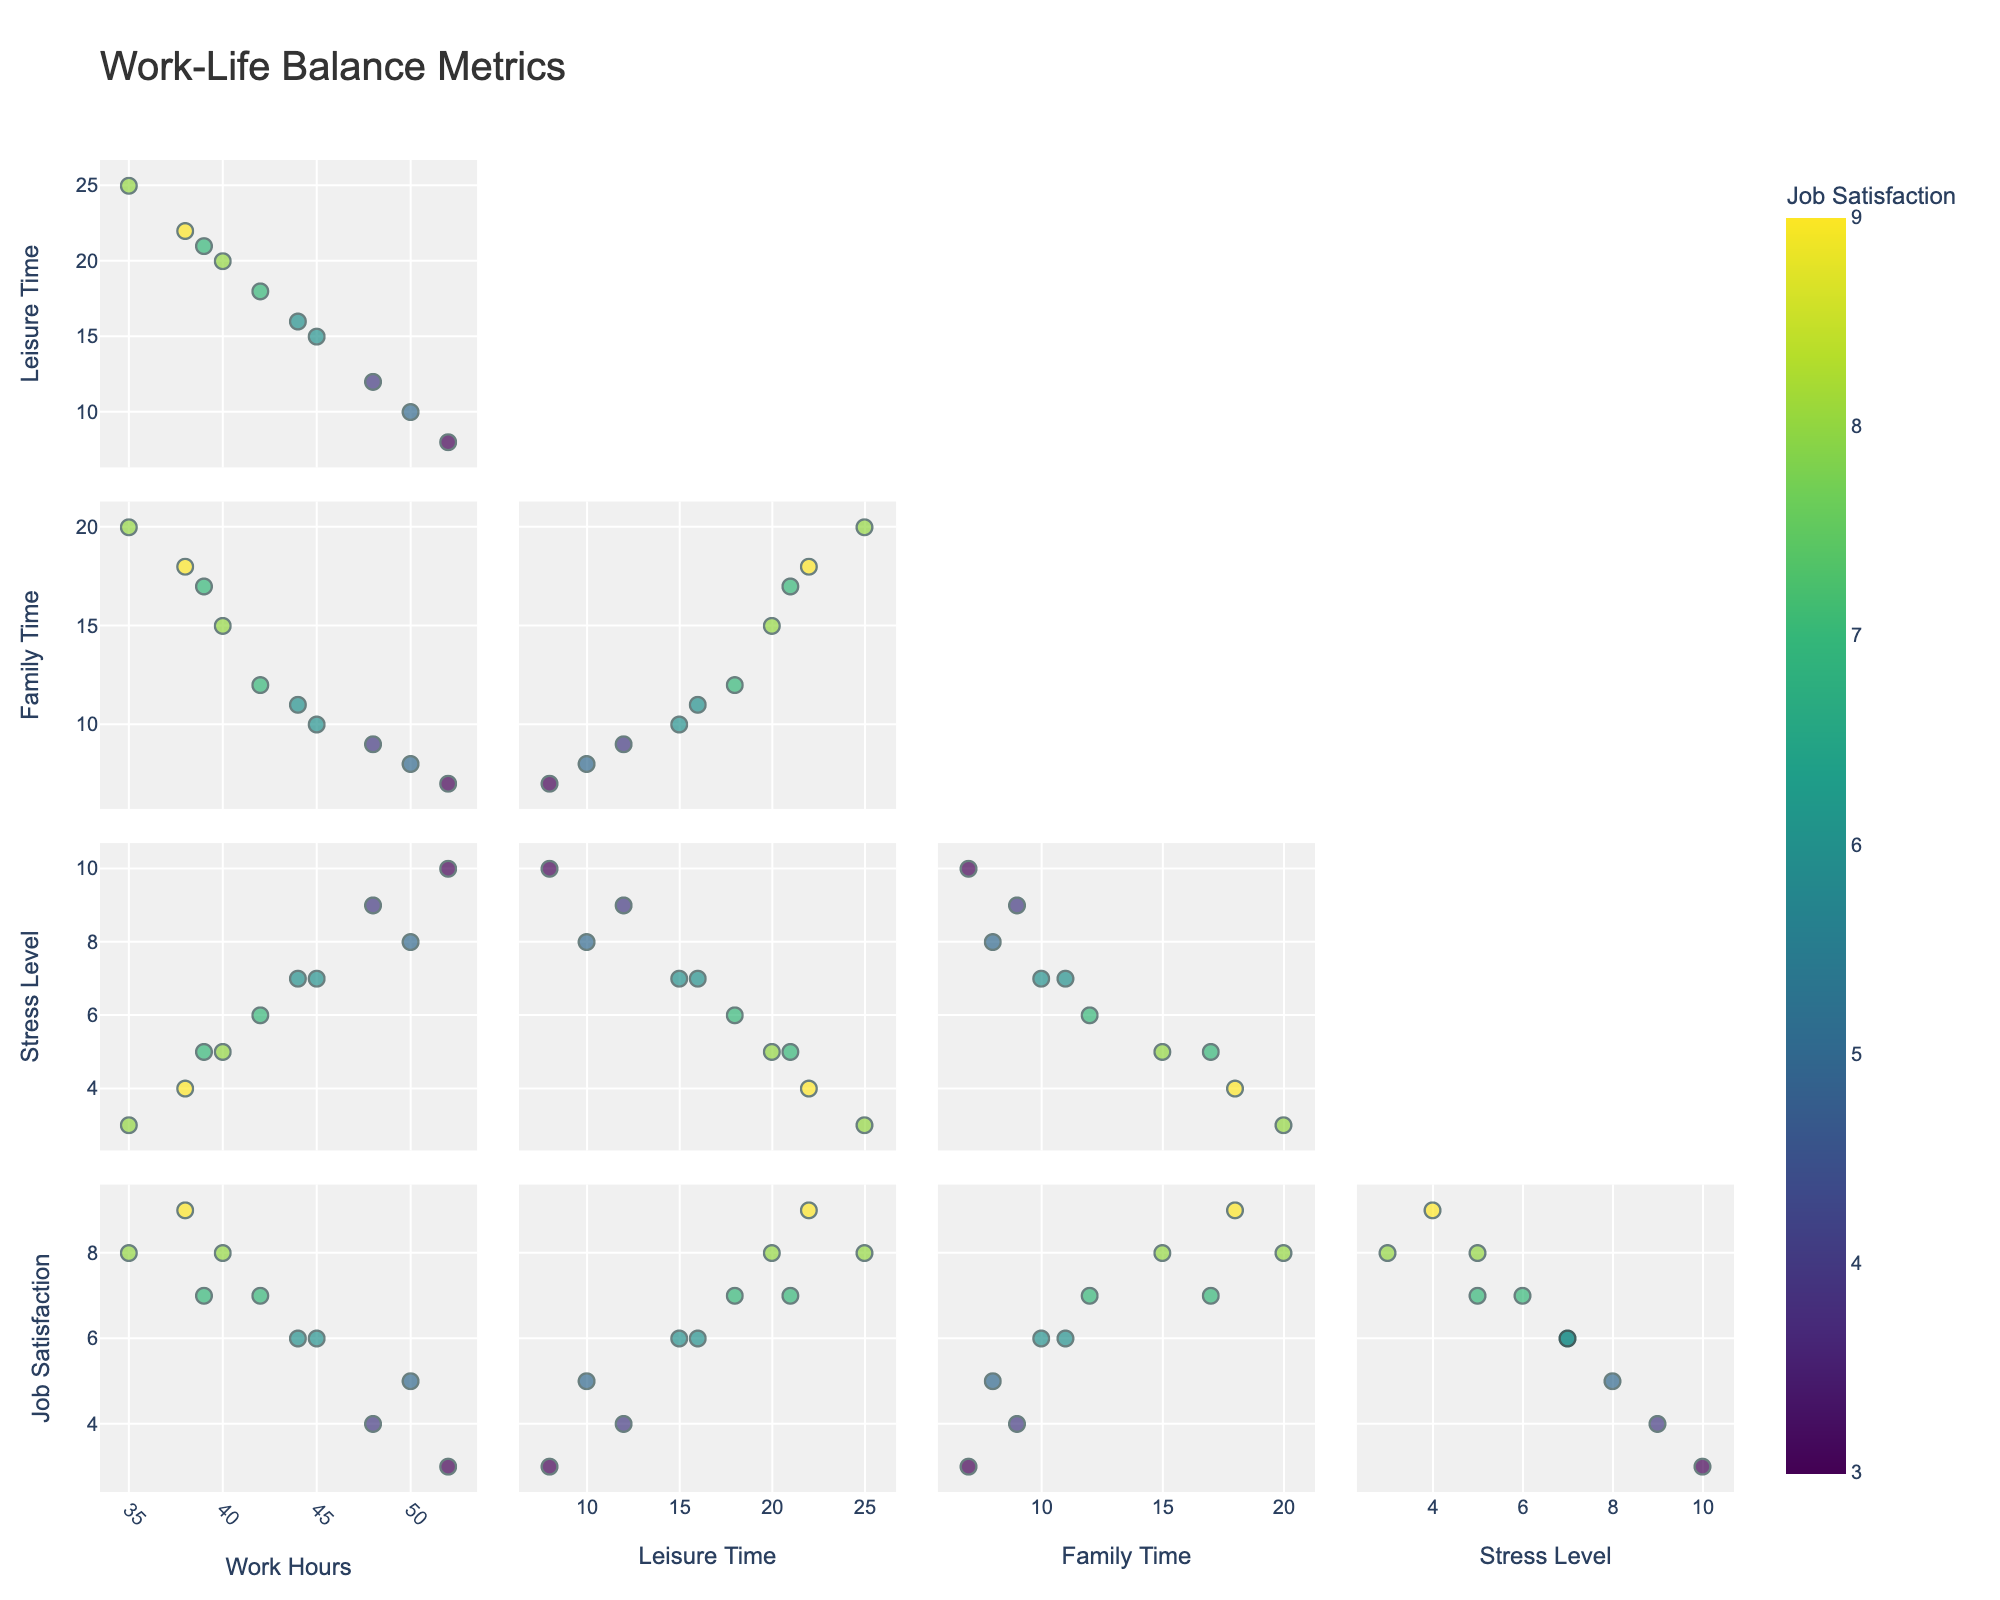How many subplots are present in the figure? There are three subplots in the figure, each representing a different fish species: Amazon Catfish, Peacock Bass, and Piranha.
Answer: 3 What is the title of the entire figure? The title of the entire figure is located at the top and reads "River Fish Populations vs Rainfall."
Answer: River Fish Populations vs Rainfall Which fish species has the highest population in the year with the maximum rainfall? The year with the maximum rainfall is 2005, with 2400 mm. In 2005, the fish populations are as follows: Amazon Catfish (1450), Peacock Bass (1050), and Piranha (1800). Piranha has the highest population in this year.
Answer: Piranha What is the average population of the Amazon Catfish over the years shown in the figure? To find the average population of Amazon Catfish: (1200 + 1350 + 1150 + 1450 + 1050 + 1300 + 1250) / 7 = 8750 / 7 = 1250.
Answer: 1250 Which species shows the most variation in population relative to the rainfall across the years? By visually comparing the scatter plots, we observe that the Piranha population shows the most noticeable fluctuations in population relative to rainfall across the years.
Answer: Piranha Compare the population of Peacock Bass in years with rainfall above 2200 mm and below 2200 mm. Which is higher? Rainfall above 2200 mm includes years 1995 (950) and 2005 (1050). Rainfall below 2200 mm includes 1990 (800), 2000 (750), 2010 (700), 2015 (900), and 2020 (850). Sum over 2200 mm: 950 + 1050 = 2000. Sum below 2200 mm: 800 + 750 + 700 + 900 + 850 = 4000. Population is higher in years with rainfall below 2200 mm.
Answer: Below 2200 mm What is the population difference between Amazon Catfish and Piranha in 1995? In 1995, Amazon Catfish population is 1350 and Piranha population is 1650. The difference is 1650 - 1350 = 300.
Answer: 300 During which period did the Peacock Bass population rise the most sharply? By examining the plot, the most significant increase in Peacock Bass population occurs between 2000 and 2005, rising from 750 to 1050, an increase of 300.
Answer: 2000-2005 Which year shows the lowest overall fish population across all species? In 2010, the populations are: Amazon Catfish (1050), Peacock Bass (700), and Piranha (1300). The total is 3050, which is the lowest among all years.
Answer: 2010 